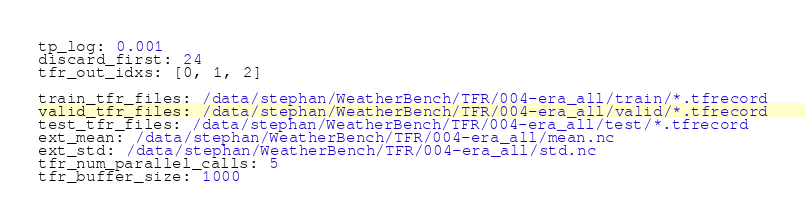Convert code to text. <code><loc_0><loc_0><loc_500><loc_500><_YAML_>tp_log: 0.001
discard_first: 24
tfr_out_idxs: [0, 1, 2]

train_tfr_files: /data/stephan/WeatherBench/TFR/004-era_all/train/*.tfrecord
valid_tfr_files: /data/stephan/WeatherBench/TFR/004-era_all/valid/*.tfrecord
test_tfr_files: /data/stephan/WeatherBench/TFR/004-era_all/test/*.tfrecord
ext_mean: /data/stephan/WeatherBench/TFR/004-era_all/mean.nc
ext_std: /data/stephan/WeatherBench/TFR/004-era_all/std.nc
tfr_num_parallel_calls: 5
tfr_buffer_size: 1000</code> 